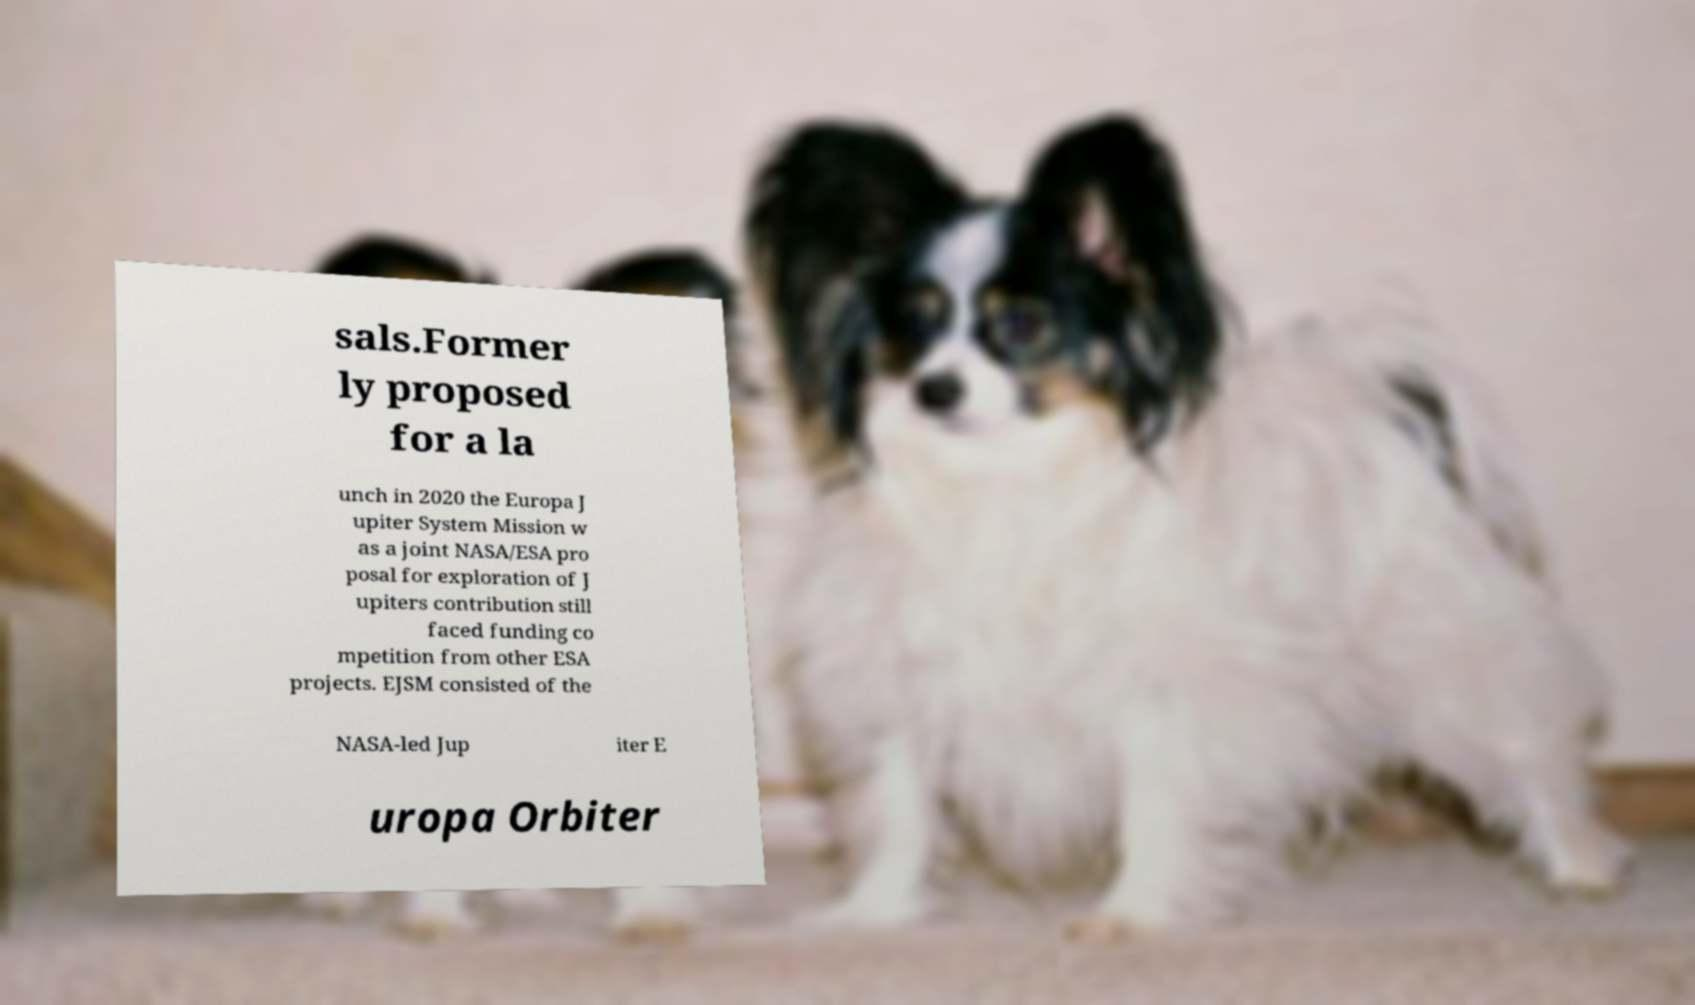Can you accurately transcribe the text from the provided image for me? sals.Former ly proposed for a la unch in 2020 the Europa J upiter System Mission w as a joint NASA/ESA pro posal for exploration of J upiters contribution still faced funding co mpetition from other ESA projects. EJSM consisted of the NASA-led Jup iter E uropa Orbiter 